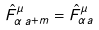Convert formula to latex. <formula><loc_0><loc_0><loc_500><loc_500>\hat { F } ^ { \mu } _ { \alpha \, a + m } = \hat { F } ^ { \mu } _ { \alpha a }</formula> 